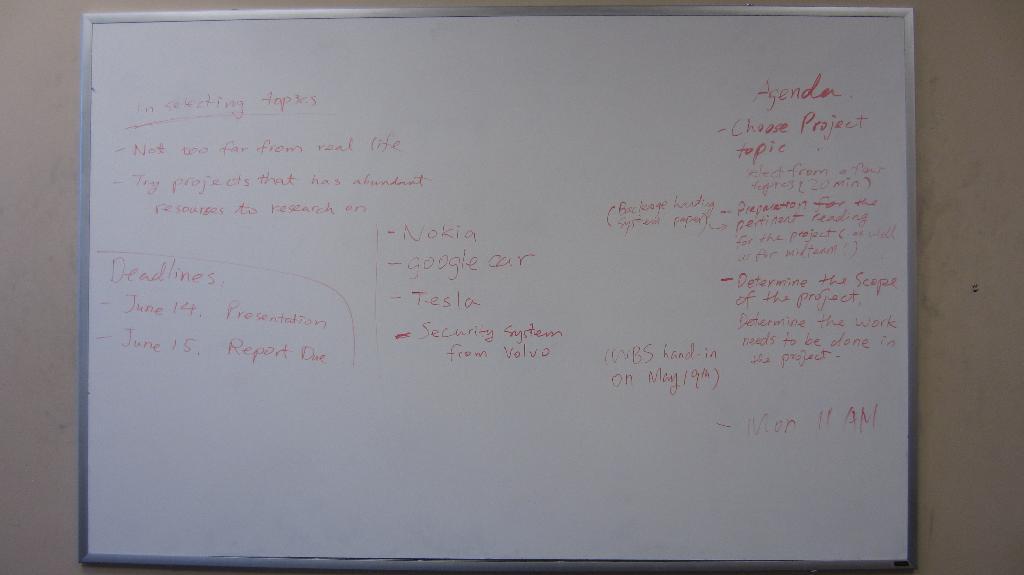What is the first item on the agenda?
Your response must be concise. Choose project topic. When are the two deadlines?
Your answer should be compact. June 14, june 15. 